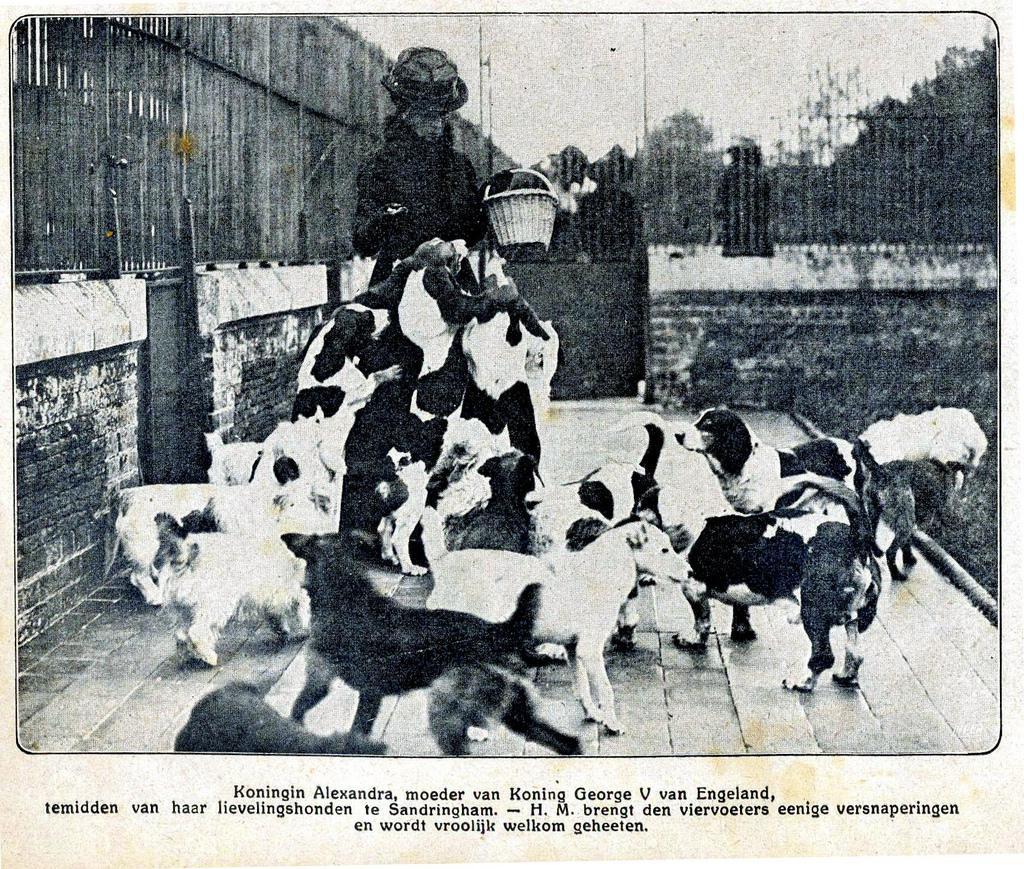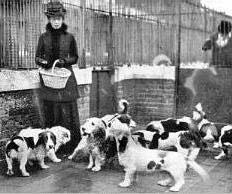The first image is the image on the left, the second image is the image on the right. Considering the images on both sides, is "Both images show at least one person standing behind a pack of hound dogs." valid? Answer yes or no. Yes. 